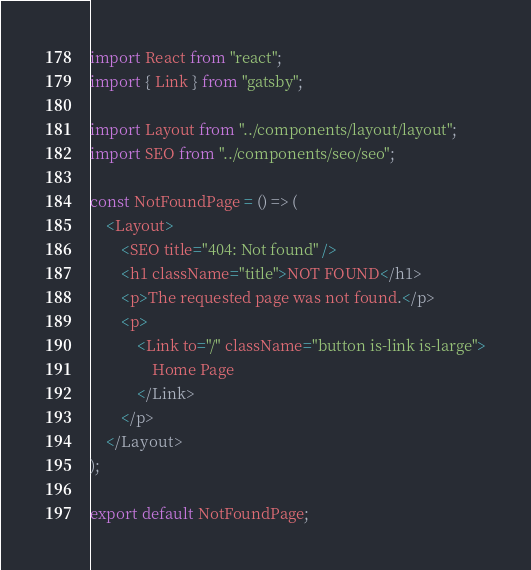Convert code to text. <code><loc_0><loc_0><loc_500><loc_500><_JavaScript_>import React from "react";
import { Link } from "gatsby";

import Layout from "../components/layout/layout";
import SEO from "../components/seo/seo";

const NotFoundPage = () => (
    <Layout>
        <SEO title="404: Not found" />
        <h1 className="title">NOT FOUND</h1>
        <p>The requested page was not found.</p>
        <p>
            <Link to="/" className="button is-link is-large">
                Home Page
            </Link>
        </p>
    </Layout>
);

export default NotFoundPage;
</code> 